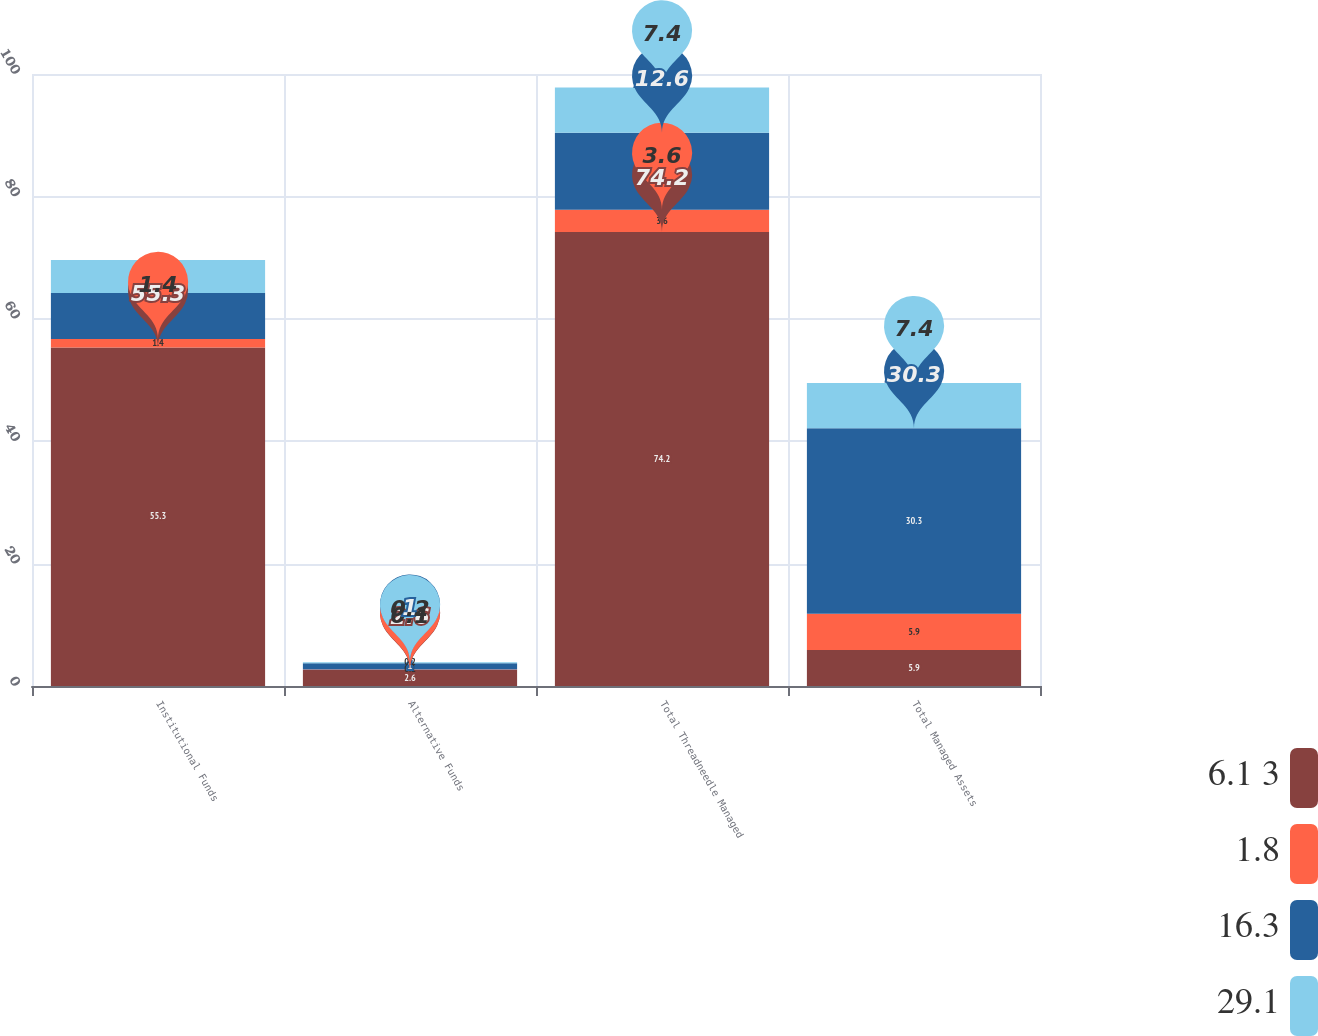Convert chart. <chart><loc_0><loc_0><loc_500><loc_500><stacked_bar_chart><ecel><fcel>Institutional Funds<fcel>Alternative Funds<fcel>Total Threadneedle Managed<fcel>Total Managed Assets<nl><fcel>6.1 3<fcel>55.3<fcel>2.6<fcel>74.2<fcel>5.9<nl><fcel>1.8<fcel>1.4<fcel>0.1<fcel>3.6<fcel>5.9<nl><fcel>16.3<fcel>7.5<fcel>1<fcel>12.6<fcel>30.3<nl><fcel>29.1<fcel>5.4<fcel>0.2<fcel>7.4<fcel>7.4<nl></chart> 